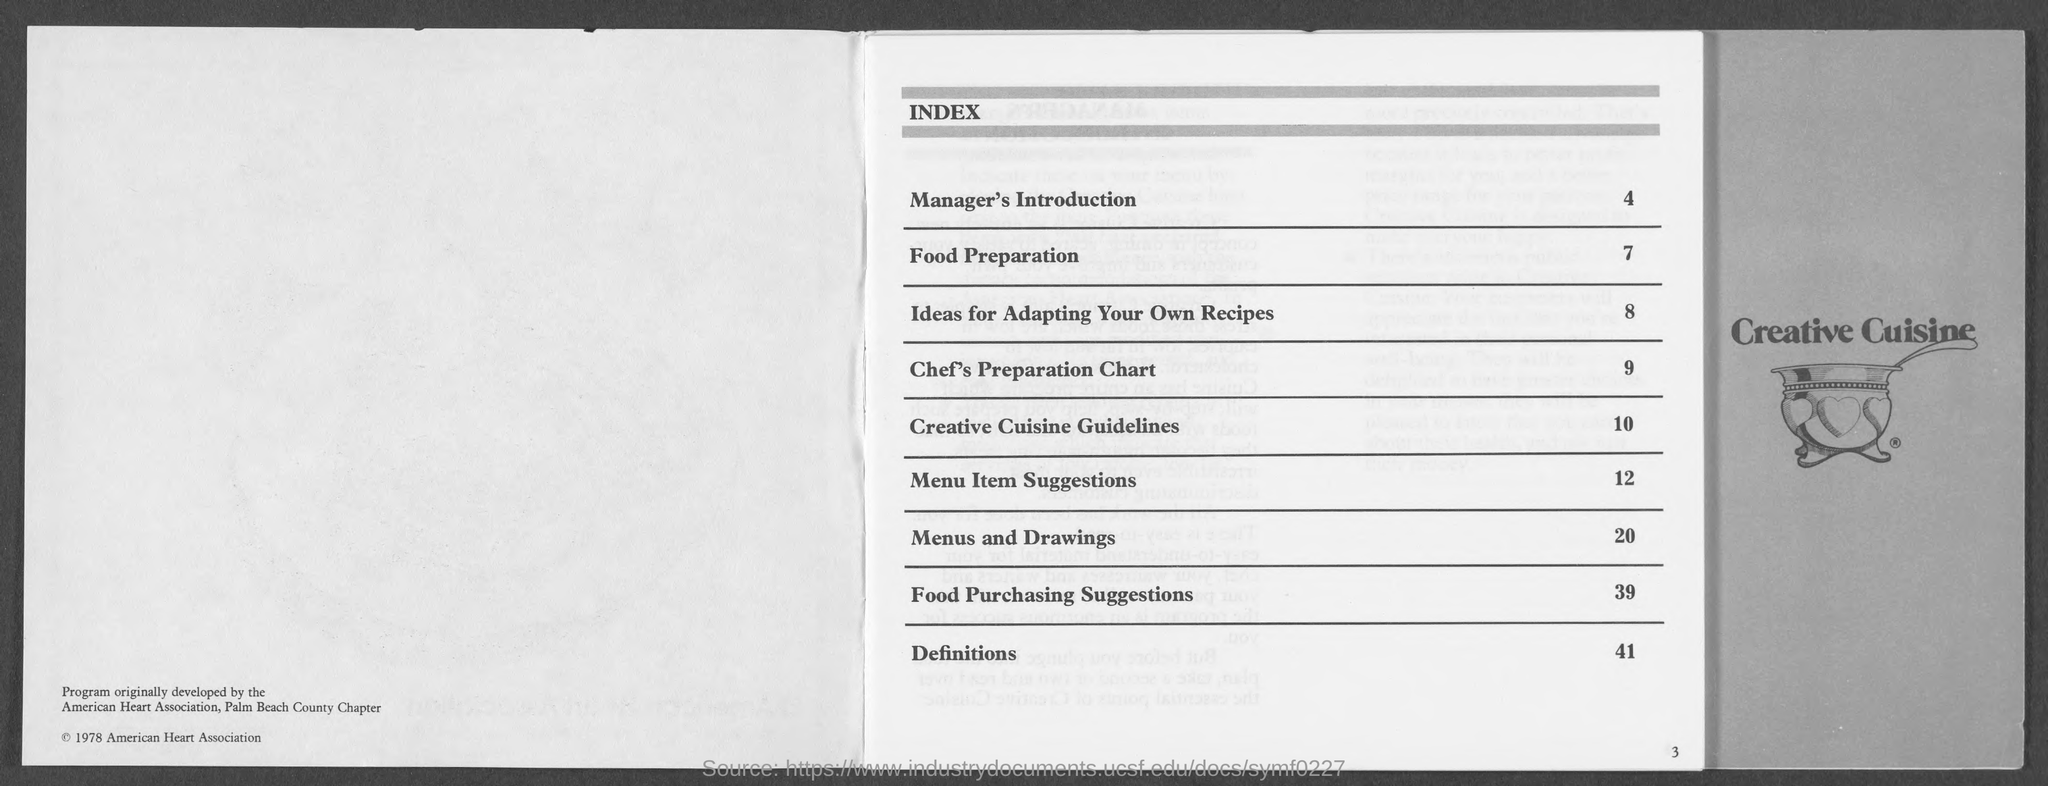What  is there in the page 4 ?
Provide a succinct answer. Manager's Introduction. What is the page number of food preparation ?
Provide a short and direct response. 7. What is there in page 9 ?
Provide a succinct answer. Chef's Preparation Chart. What is there in page 20 ?
Ensure brevity in your answer.  Menus and Drawings. What is there in page no.41 ?
Provide a succinct answer. Definitions. What is there in page 10 ?
Provide a short and direct response. Creative cuisine guidelines. 